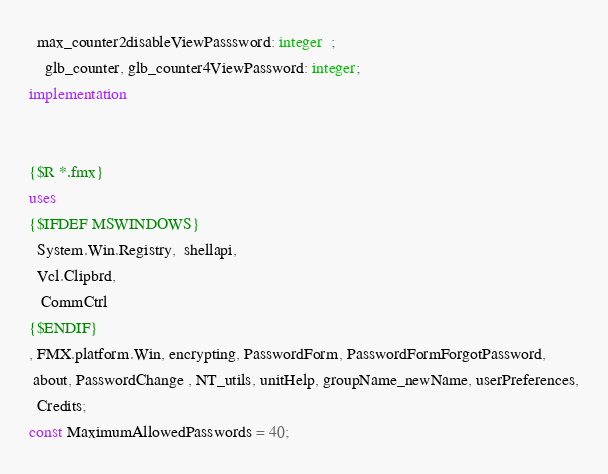Convert code to text. <code><loc_0><loc_0><loc_500><loc_500><_Pascal_>  max_counter2disableViewPasssword: integer  ;
    glb_counter, glb_counter4ViewPassword: integer;
implementation


{$R *.fmx}
uses
{$IFDEF MSWINDOWS}
  System.Win.Registry,  shellapi,
  Vcl.Clipbrd,
   CommCtrl
{$ENDIF}
, FMX.platform.Win, encrypting, PasswordForm, PasswordFormForgotPassword,
 about, PasswordChange , NT_utils, unitHelp, groupName_newName, userPreferences,
  Credits;
const MaximumAllowedPasswords = 40;


</code> 